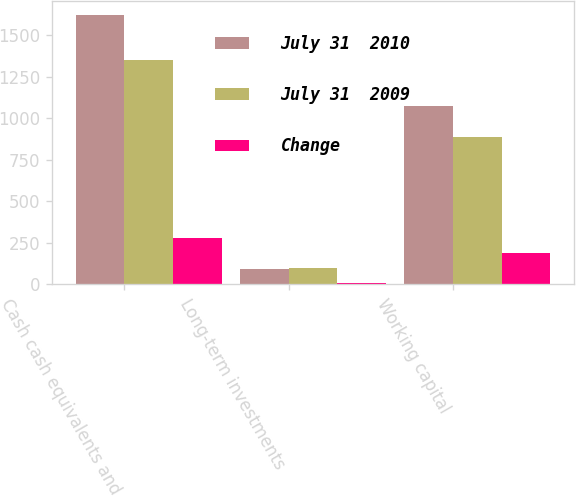<chart> <loc_0><loc_0><loc_500><loc_500><stacked_bar_chart><ecel><fcel>Cash cash equivalents and<fcel>Long-term investments<fcel>Working capital<nl><fcel>July 31  2010<fcel>1622<fcel>91<fcel>1074<nl><fcel>July 31  2009<fcel>1347<fcel>97<fcel>884<nl><fcel>Change<fcel>275<fcel>6<fcel>190<nl></chart> 